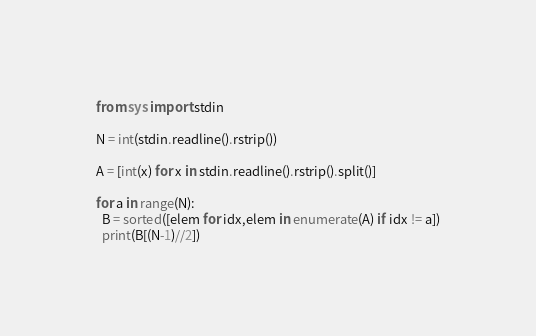Convert code to text. <code><loc_0><loc_0><loc_500><loc_500><_Python_>from sys import stdin
 
N = int(stdin.readline().rstrip())
 
A = [int(x) for x in stdin.readline().rstrip().split()]
 
for a in range(N):  
  B = sorted([elem for idx,elem in enumerate(A) if idx != a])
  print(B[(N-1)//2])</code> 